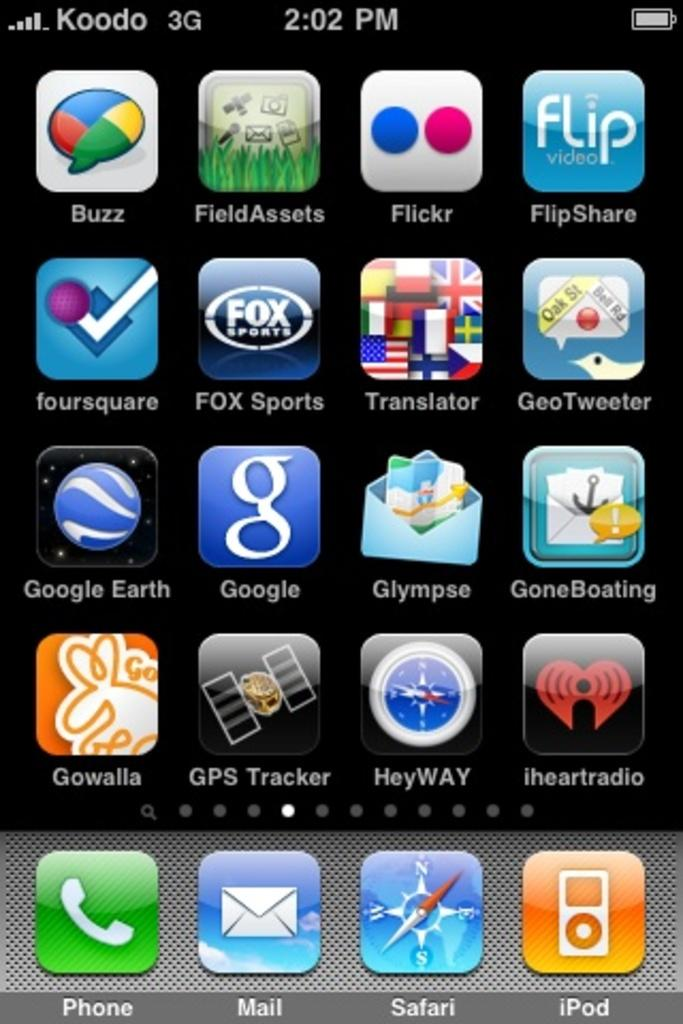<image>
Give a short and clear explanation of the subsequent image. A phone on the Koodo 3G Network displays a page full of various apps such as Flipshare and Heyway. 